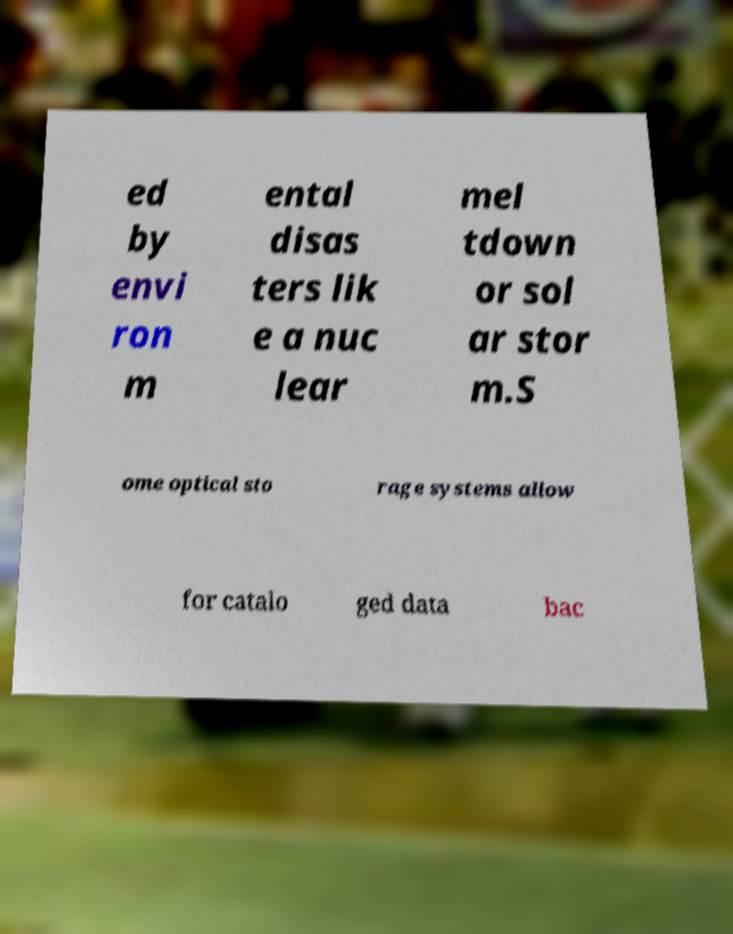I need the written content from this picture converted into text. Can you do that? ed by envi ron m ental disas ters lik e a nuc lear mel tdown or sol ar stor m.S ome optical sto rage systems allow for catalo ged data bac 